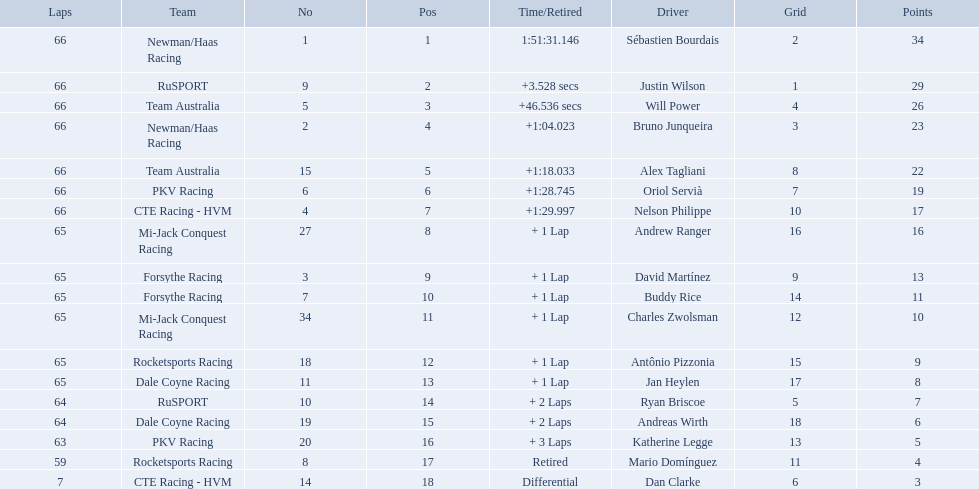What drivers started in the top 10? Sébastien Bourdais, Justin Wilson, Will Power, Bruno Junqueira, Alex Tagliani, Oriol Servià, Nelson Philippe, Ryan Briscoe, Dan Clarke. Which of those drivers completed all 66 laps? Sébastien Bourdais, Justin Wilson, Will Power, Bruno Junqueira, Alex Tagliani, Oriol Servià, Nelson Philippe. Whom of these did not drive for team australia? Sébastien Bourdais, Justin Wilson, Bruno Junqueira, Oriol Servià, Nelson Philippe. Which of these drivers finished more then a minuet after the winner? Bruno Junqueira, Oriol Servià, Nelson Philippe. Which of these drivers had the highest car number? Oriol Servià. Which teams participated in the 2006 gran premio telmex? Newman/Haas Racing, RuSPORT, Team Australia, Newman/Haas Racing, Team Australia, PKV Racing, CTE Racing - HVM, Mi-Jack Conquest Racing, Forsythe Racing, Forsythe Racing, Mi-Jack Conquest Racing, Rocketsports Racing, Dale Coyne Racing, RuSPORT, Dale Coyne Racing, PKV Racing, Rocketsports Racing, CTE Racing - HVM. Who were the drivers of these teams? Sébastien Bourdais, Justin Wilson, Will Power, Bruno Junqueira, Alex Tagliani, Oriol Servià, Nelson Philippe, Andrew Ranger, David Martínez, Buddy Rice, Charles Zwolsman, Antônio Pizzonia, Jan Heylen, Ryan Briscoe, Andreas Wirth, Katherine Legge, Mario Domínguez, Dan Clarke. Which driver finished last? Dan Clarke. 